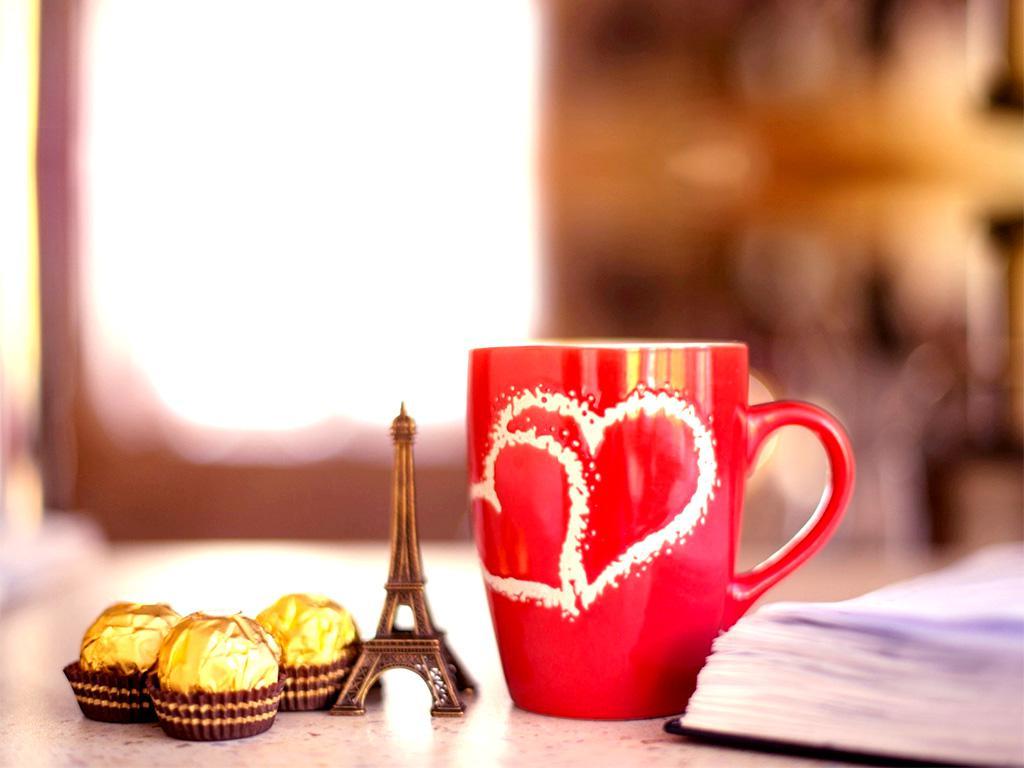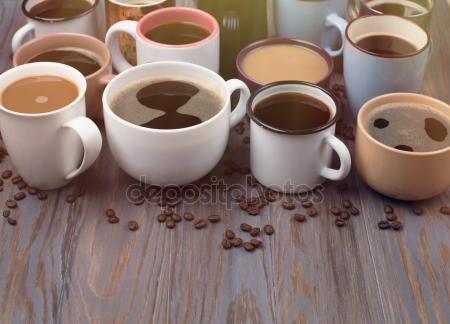The first image is the image on the left, the second image is the image on the right. Evaluate the accuracy of this statement regarding the images: "There are fewer than ten cups in total.". Is it true? Answer yes or no. No. The first image is the image on the left, the second image is the image on the right. Examine the images to the left and right. Is the description "In at least one image there is a total of four cups." accurate? Answer yes or no. No. 